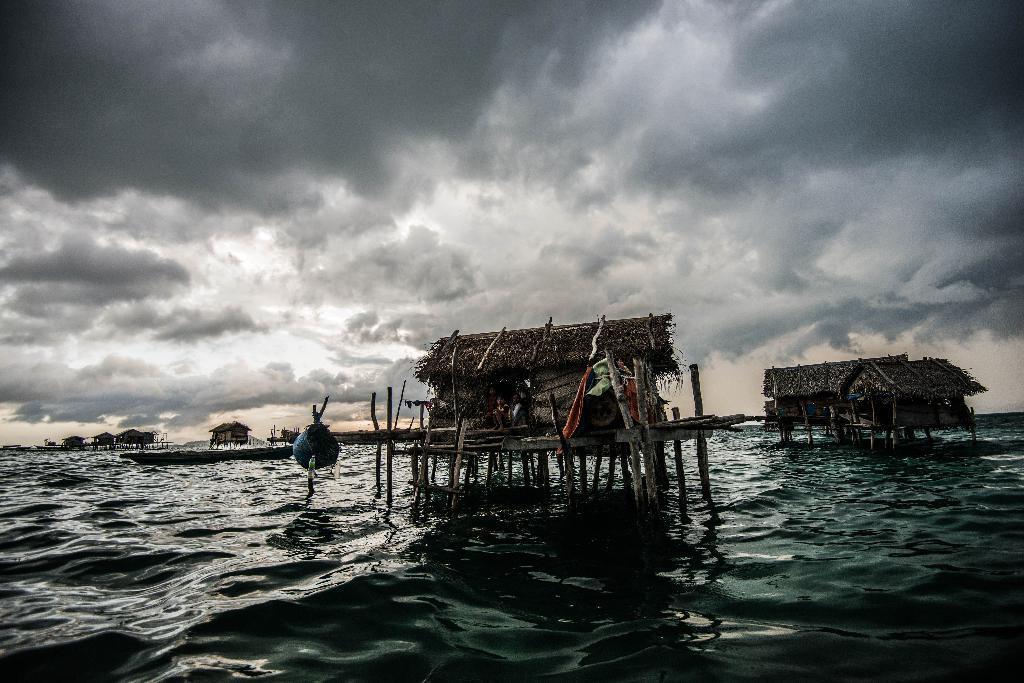Describe this image in one or two sentences. In this image I can see the water and in the middle of the water I can see few huts, background the sky is in white and gray color. 